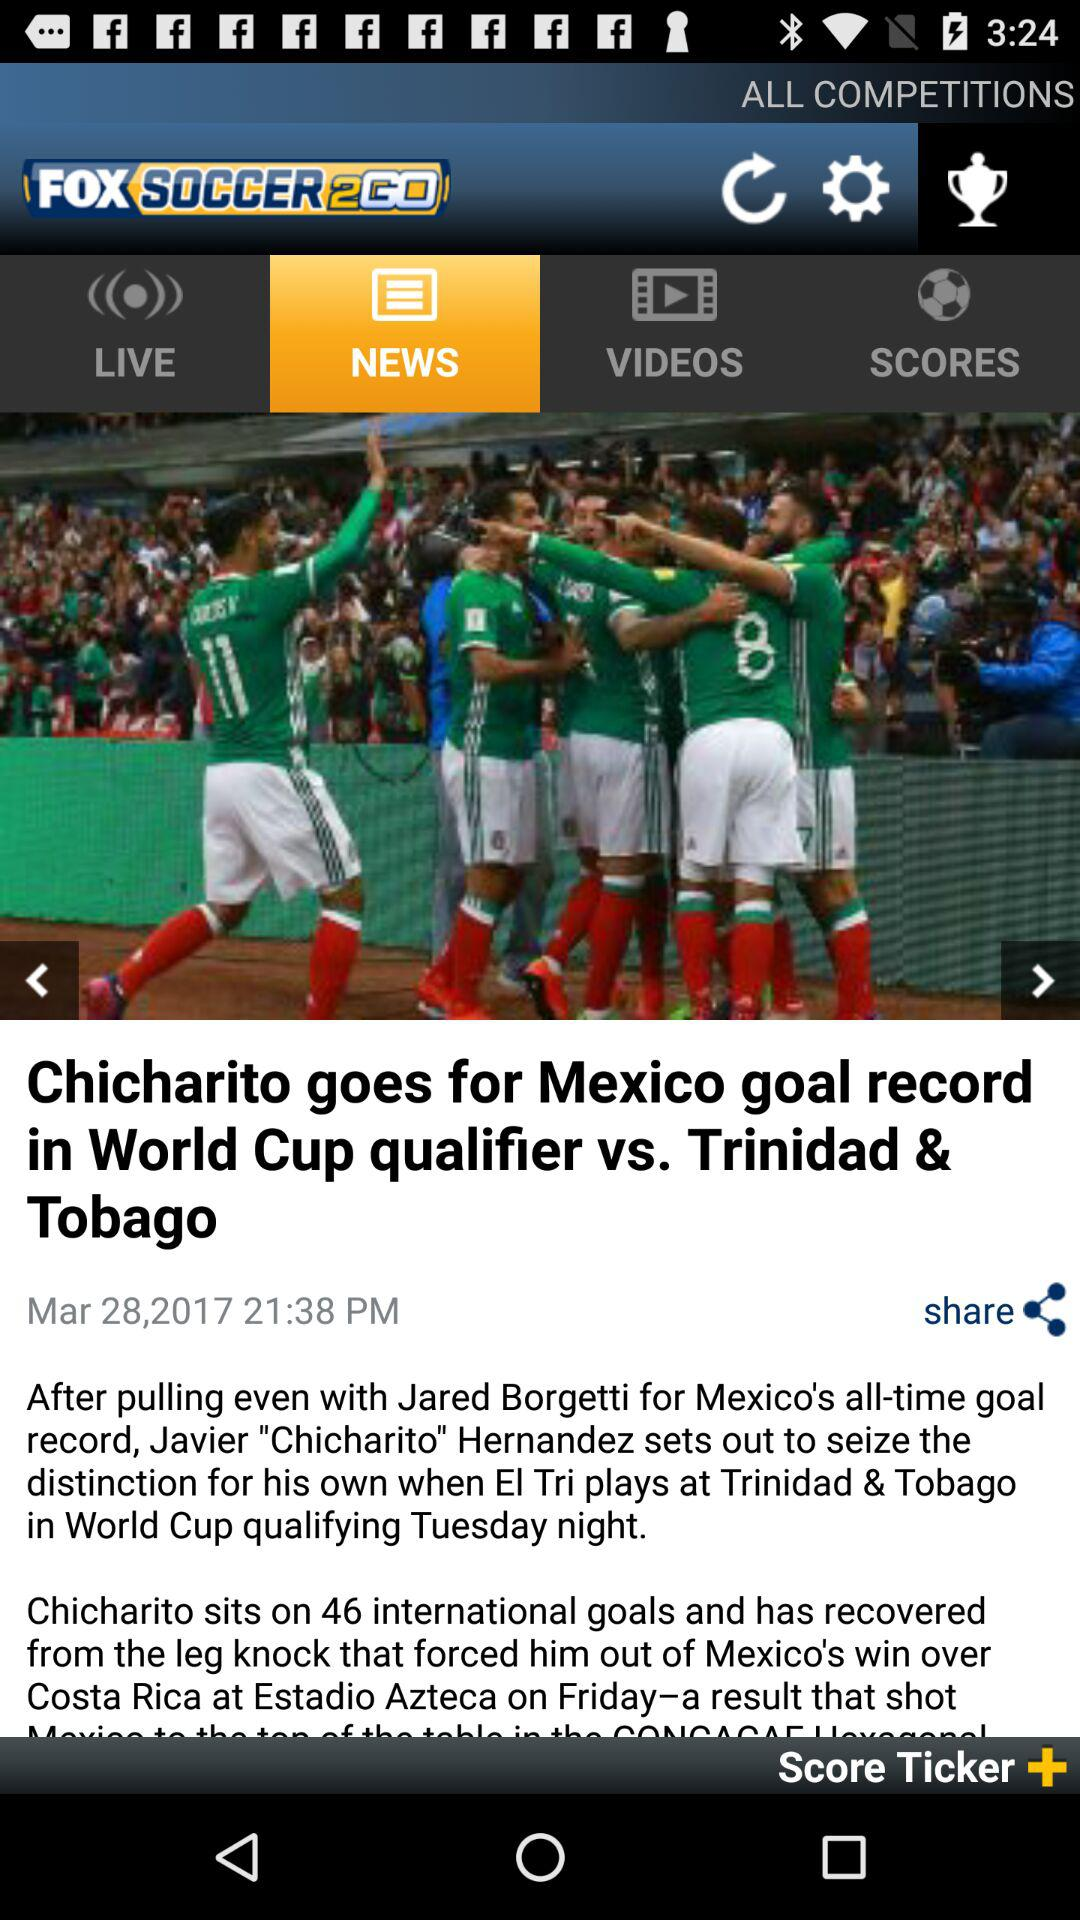What is the name of the application? The application name is "FOX SOCCER 2GO". 